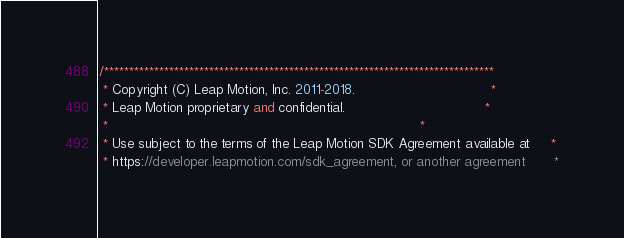Convert code to text. <code><loc_0><loc_0><loc_500><loc_500><_C#_>/******************************************************************************
 * Copyright (C) Leap Motion, Inc. 2011-2018.                                 *
 * Leap Motion proprietary and confidential.                                  *
 *                                                                            *
 * Use subject to the terms of the Leap Motion SDK Agreement available at     *
 * https://developer.leapmotion.com/sdk_agreement, or another agreement       *</code> 